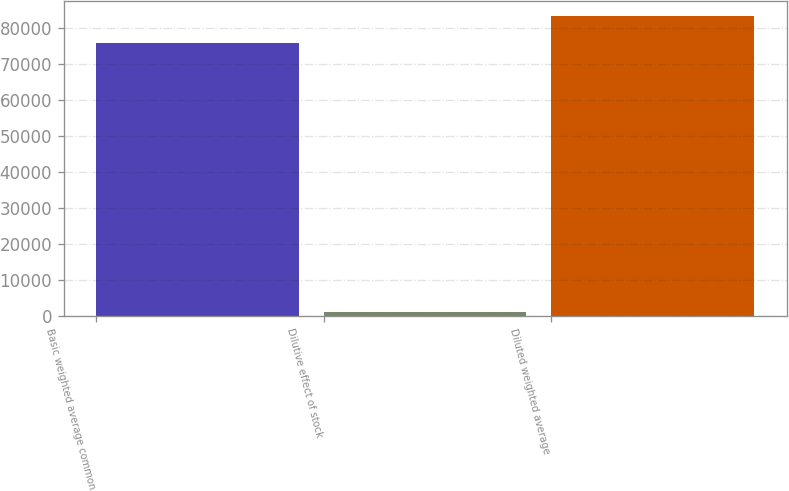<chart> <loc_0><loc_0><loc_500><loc_500><bar_chart><fcel>Basic weighted average common<fcel>Dilutive effect of stock<fcel>Diluted weighted average<nl><fcel>75803<fcel>955<fcel>83383.3<nl></chart> 